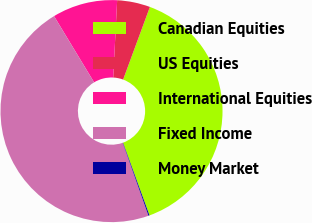Convert chart to OTSL. <chart><loc_0><loc_0><loc_500><loc_500><pie_chart><fcel>Canadian Equities<fcel>US Equities<fcel>International Equities<fcel>Fixed Income<fcel>Money Market<nl><fcel>38.82%<fcel>4.81%<fcel>9.47%<fcel>46.74%<fcel>0.15%<nl></chart> 